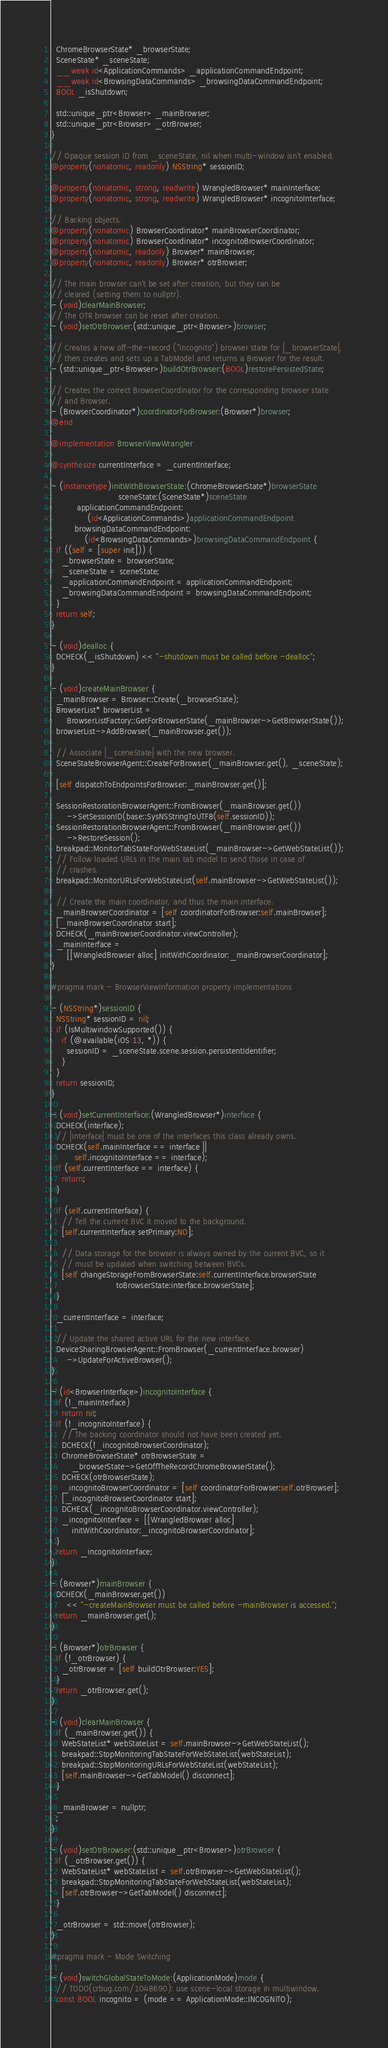Convert code to text. <code><loc_0><loc_0><loc_500><loc_500><_ObjectiveC_>  ChromeBrowserState* _browserState;
  SceneState* _sceneState;
  __weak id<ApplicationCommands> _applicationCommandEndpoint;
  __weak id<BrowsingDataCommands> _browsingDataCommandEndpoint;
  BOOL _isShutdown;

  std::unique_ptr<Browser> _mainBrowser;
  std::unique_ptr<Browser> _otrBrowser;
}

// Opaque session ID from _sceneState, nil when multi-window isn't enabled.
@property(nonatomic, readonly) NSString* sessionID;

@property(nonatomic, strong, readwrite) WrangledBrowser* mainInterface;
@property(nonatomic, strong, readwrite) WrangledBrowser* incognitoInterface;

// Backing objects.
@property(nonatomic) BrowserCoordinator* mainBrowserCoordinator;
@property(nonatomic) BrowserCoordinator* incognitoBrowserCoordinator;
@property(nonatomic, readonly) Browser* mainBrowser;
@property(nonatomic, readonly) Browser* otrBrowser;

// The main browser can't be set after creation, but they can be
// cleared (setting them to nullptr).
- (void)clearMainBrowser;
// The OTR browser can be reset after creation.
- (void)setOtrBrowser:(std::unique_ptr<Browser>)browser;

// Creates a new off-the-record ("incognito") browser state for |_browserState|,
// then creates and sets up a TabModel and returns a Browser for the result.
- (std::unique_ptr<Browser>)buildOtrBrowser:(BOOL)restorePersistedState;

// Creates the correct BrowserCoordinator for the corresponding browser state
// and Browser.
- (BrowserCoordinator*)coordinatorForBrowser:(Browser*)browser;
@end

@implementation BrowserViewWrangler

@synthesize currentInterface = _currentInterface;

- (instancetype)initWithBrowserState:(ChromeBrowserState*)browserState
                          sceneState:(SceneState*)sceneState
          applicationCommandEndpoint:
              (id<ApplicationCommands>)applicationCommandEndpoint
         browsingDataCommandEndpoint:
             (id<BrowsingDataCommands>)browsingDataCommandEndpoint {
  if ((self = [super init])) {
    _browserState = browserState;
    _sceneState = sceneState;
    _applicationCommandEndpoint = applicationCommandEndpoint;
    _browsingDataCommandEndpoint = browsingDataCommandEndpoint;
  }
  return self;
}

- (void)dealloc {
  DCHECK(_isShutdown) << "-shutdown must be called before -dealloc";
}

- (void)createMainBrowser {
  _mainBrowser = Browser::Create(_browserState);
  BrowserList* browserList =
      BrowserListFactory::GetForBrowserState(_mainBrowser->GetBrowserState());
  browserList->AddBrowser(_mainBrowser.get());

  // Associate |_sceneState| with the new browser.
  SceneStateBrowserAgent::CreateForBrowser(_mainBrowser.get(), _sceneState);

  [self dispatchToEndpointsForBrowser:_mainBrowser.get()];

  SessionRestorationBrowserAgent::FromBrowser(_mainBrowser.get())
      ->SetSessionID(base::SysNSStringToUTF8(self.sessionID));
  SessionRestorationBrowserAgent::FromBrowser(_mainBrowser.get())
      ->RestoreSession();
  breakpad::MonitorTabStateForWebStateList(_mainBrowser->GetWebStateList());
  // Follow loaded URLs in the main tab model to send those in case of
  // crashes.
  breakpad::MonitorURLsForWebStateList(self.mainBrowser->GetWebStateList());

  // Create the main coordinator, and thus the main interface.
  _mainBrowserCoordinator = [self coordinatorForBrowser:self.mainBrowser];
  [_mainBrowserCoordinator start];
  DCHECK(_mainBrowserCoordinator.viewController);
  _mainInterface =
      [[WrangledBrowser alloc] initWithCoordinator:_mainBrowserCoordinator];
}

#pragma mark - BrowserViewInformation property implementations

- (NSString*)sessionID {
  NSString* sessionID = nil;
  if (IsMultiwindowSupported()) {
    if (@available(iOS 13, *)) {
      sessionID = _sceneState.scene.session.persistentIdentifier;
    }
  }
  return sessionID;
}

- (void)setCurrentInterface:(WrangledBrowser*)interface {
  DCHECK(interface);
  // |interface| must be one of the interfaces this class already owns.
  DCHECK(self.mainInterface == interface ||
         self.incognitoInterface == interface);
  if (self.currentInterface == interface) {
    return;
  }

  if (self.currentInterface) {
    // Tell the current BVC it moved to the background.
    [self.currentInterface setPrimary:NO];

    // Data storage for the browser is always owned by the current BVC, so it
    // must be updated when switching between BVCs.
    [self changeStorageFromBrowserState:self.currentInterface.browserState
                         toBrowserState:interface.browserState];
  }

  _currentInterface = interface;

  // Update the shared active URL for the new interface.
  DeviceSharingBrowserAgent::FromBrowser(_currentInterface.browser)
      ->UpdateForActiveBrowser();
}

- (id<BrowserInterface>)incognitoInterface {
  if (!_mainInterface)
    return nil;
  if (!_incognitoInterface) {
    // The backing coordinator should not have been created yet.
    DCHECK(!_incognitoBrowserCoordinator);
    ChromeBrowserState* otrBrowserState =
        _browserState->GetOffTheRecordChromeBrowserState();
    DCHECK(otrBrowserState);
    _incognitoBrowserCoordinator = [self coordinatorForBrowser:self.otrBrowser];
    [_incognitoBrowserCoordinator start];
    DCHECK(_incognitoBrowserCoordinator.viewController);
    _incognitoInterface = [[WrangledBrowser alloc]
        initWithCoordinator:_incognitoBrowserCoordinator];
  }
  return _incognitoInterface;
}

- (Browser*)mainBrowser {
  DCHECK(_mainBrowser.get())
      << "-createMainBrowser must be called before -mainBrowser is accessed.";
  return _mainBrowser.get();
}

- (Browser*)otrBrowser {
  if (!_otrBrowser) {
    _otrBrowser = [self buildOtrBrowser:YES];
  }
  return _otrBrowser.get();
}

- (void)clearMainBrowser {
  if (_mainBrowser.get()) {
    WebStateList* webStateList = self.mainBrowser->GetWebStateList();
    breakpad::StopMonitoringTabStateForWebStateList(webStateList);
    breakpad::StopMonitoringURLsForWebStateList(webStateList);
    [self.mainBrowser->GetTabModel() disconnect];
  }

  _mainBrowser = nullptr;
  ;
}

- (void)setOtrBrowser:(std::unique_ptr<Browser>)otrBrowser {
  if (_otrBrowser.get()) {
    WebStateList* webStateList = self.otrBrowser->GetWebStateList();
    breakpad::StopMonitoringTabStateForWebStateList(webStateList);
    [self.otrBrowser->GetTabModel() disconnect];
  }

  _otrBrowser = std::move(otrBrowser);
}

#pragma mark - Mode Switching

- (void)switchGlobalStateToMode:(ApplicationMode)mode {
  // TODO(crbug.com/1048690): use scene-local storage in multiwindow.
  const BOOL incognito = (mode == ApplicationMode::INCOGNITO);</code> 